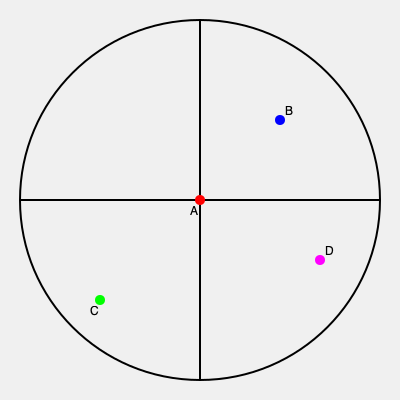In the disaster relief map above, point A represents the central aid distribution hub. If a convoy needs to visit points B, C, and D in the most efficient order before returning to A, what is the total distance traveled as a fraction of the circle's circumference? To solve this problem, we need to follow these steps:

1. Recognize that the map is divided into four quadrants, with the central point A at (0,0).
2. Estimate the coordinates of points B, C, and D:
   B: (√2/2, √2/2)
   C: (-√2/2, -√2/2)
   D: (√2/2, -√2/2)

3. Calculate the distances between points:
   AB = BC = CD = DA = √2

4. The most efficient route is A → B → D → C → A

5. Total distance = AB + BD + DC + CA = √2 + 1 + √2 + √2 = 3√2 + 1

6. The circle's radius is 1, so its circumference is 2π

7. Express the total distance as a fraction of the circumference:
   $\frac{3\sqrt{2} + 1}{2\pi}$

8. Simplify by multiplying both numerator and denominator by $\sqrt{2}$:
   $\frac{6 + \sqrt{2}}{2\sqrt{2}\pi}$
Answer: $\frac{6 + \sqrt{2}}{2\sqrt{2}\pi}$ 